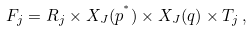Convert formula to latex. <formula><loc_0><loc_0><loc_500><loc_500>F _ { j } = R _ { j } \times X _ { J } ( p ^ { ^ { * } } ) \times X _ { J } ( q ) \times T _ { j } \, ,</formula> 